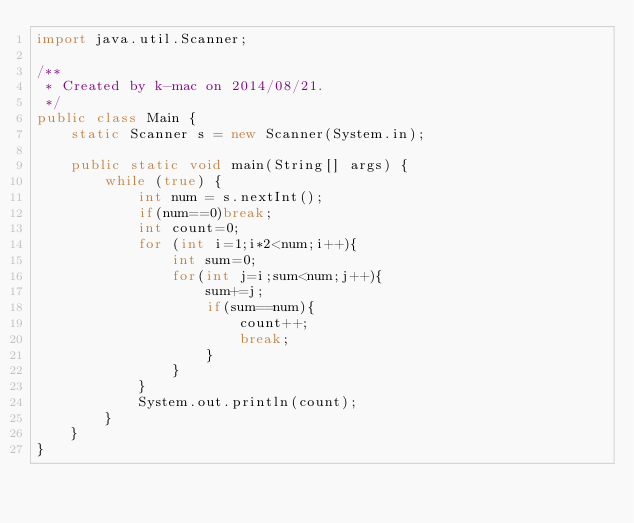Convert code to text. <code><loc_0><loc_0><loc_500><loc_500><_Java_>import java.util.Scanner;

/**
 * Created by k-mac on 2014/08/21.
 */
public class Main {
    static Scanner s = new Scanner(System.in);

    public static void main(String[] args) {
        while (true) {
            int num = s.nextInt();
            if(num==0)break;
            int count=0;
            for (int i=1;i*2<num;i++){
                int sum=0;
                for(int j=i;sum<num;j++){
                    sum+=j;
                    if(sum==num){
                        count++;
                        break;
                    }
                }
            }
            System.out.println(count);
        }
    }
}</code> 